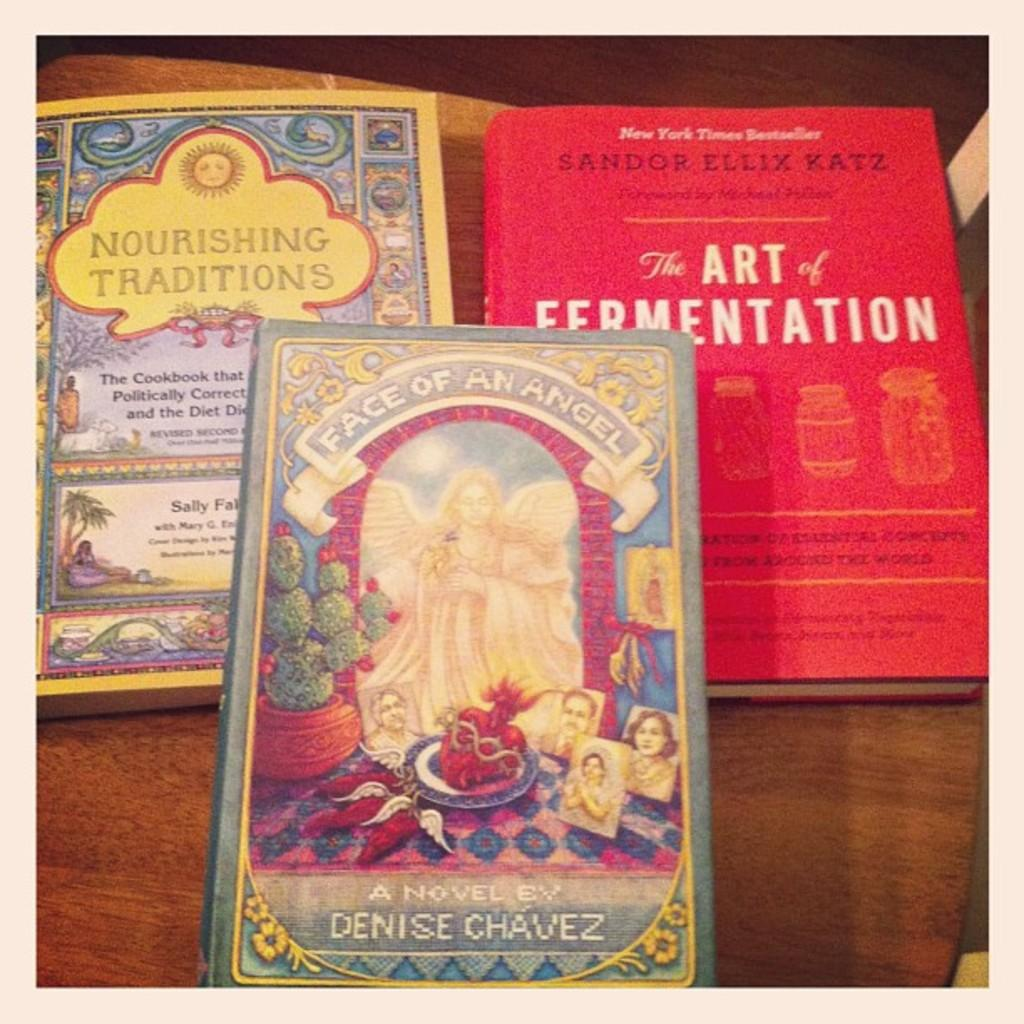<image>
Offer a succinct explanation of the picture presented. Three books entitled a Face of an Angel, the Art of Fermentation, and Nourishing Traditions. 